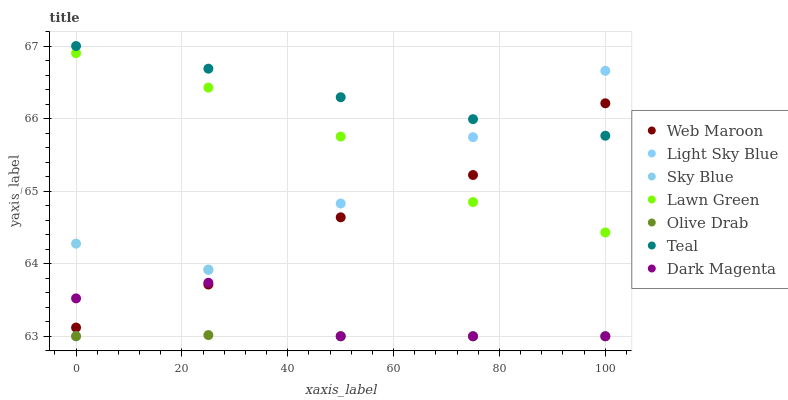Does Olive Drab have the minimum area under the curve?
Answer yes or no. Yes. Does Teal have the maximum area under the curve?
Answer yes or no. Yes. Does Dark Magenta have the minimum area under the curve?
Answer yes or no. No. Does Dark Magenta have the maximum area under the curve?
Answer yes or no. No. Is Light Sky Blue the smoothest?
Answer yes or no. Yes. Is Dark Magenta the roughest?
Answer yes or no. Yes. Is Web Maroon the smoothest?
Answer yes or no. No. Is Web Maroon the roughest?
Answer yes or no. No. Does Dark Magenta have the lowest value?
Answer yes or no. Yes. Does Web Maroon have the lowest value?
Answer yes or no. No. Does Teal have the highest value?
Answer yes or no. Yes. Does Dark Magenta have the highest value?
Answer yes or no. No. Is Lawn Green less than Teal?
Answer yes or no. Yes. Is Lawn Green greater than Sky Blue?
Answer yes or no. Yes. Does Olive Drab intersect Sky Blue?
Answer yes or no. Yes. Is Olive Drab less than Sky Blue?
Answer yes or no. No. Is Olive Drab greater than Sky Blue?
Answer yes or no. No. Does Lawn Green intersect Teal?
Answer yes or no. No. 